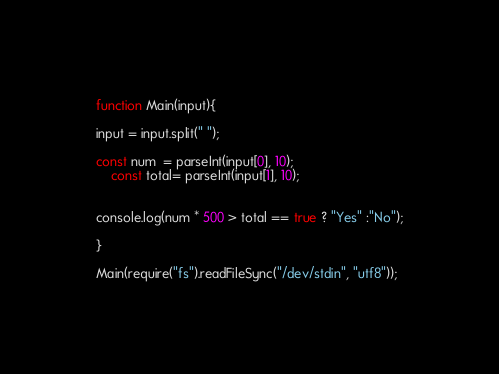Convert code to text. <code><loc_0><loc_0><loc_500><loc_500><_JavaScript_>function Main(input){
 
input = input.split(" ");

const num  = parseInt(input[0], 10);
	const total= parseInt(input[1], 10);
 

console.log(num * 500 > total == true ? "Yes" :"No");
 
}
 
Main(require("fs").readFileSync("/dev/stdin", "utf8"));</code> 